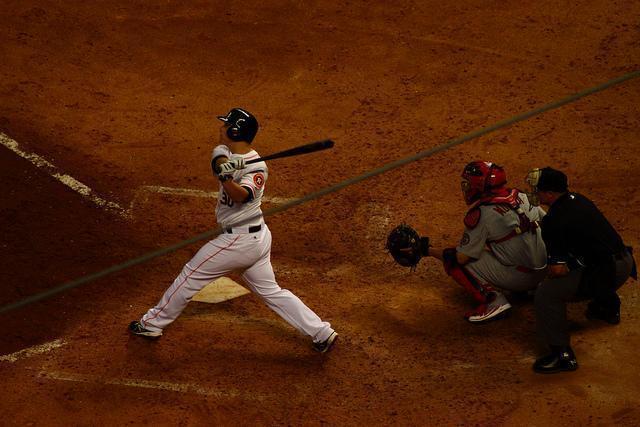What are the team colors for the team playing at pitch?
Select the correct answer and articulate reasoning with the following format: 'Answer: answer
Rationale: rationale.'
Options: Blue, purple, red, yellow. Answer: red.
Rationale: The colors appear to be a and gray. it's hard to tell. 